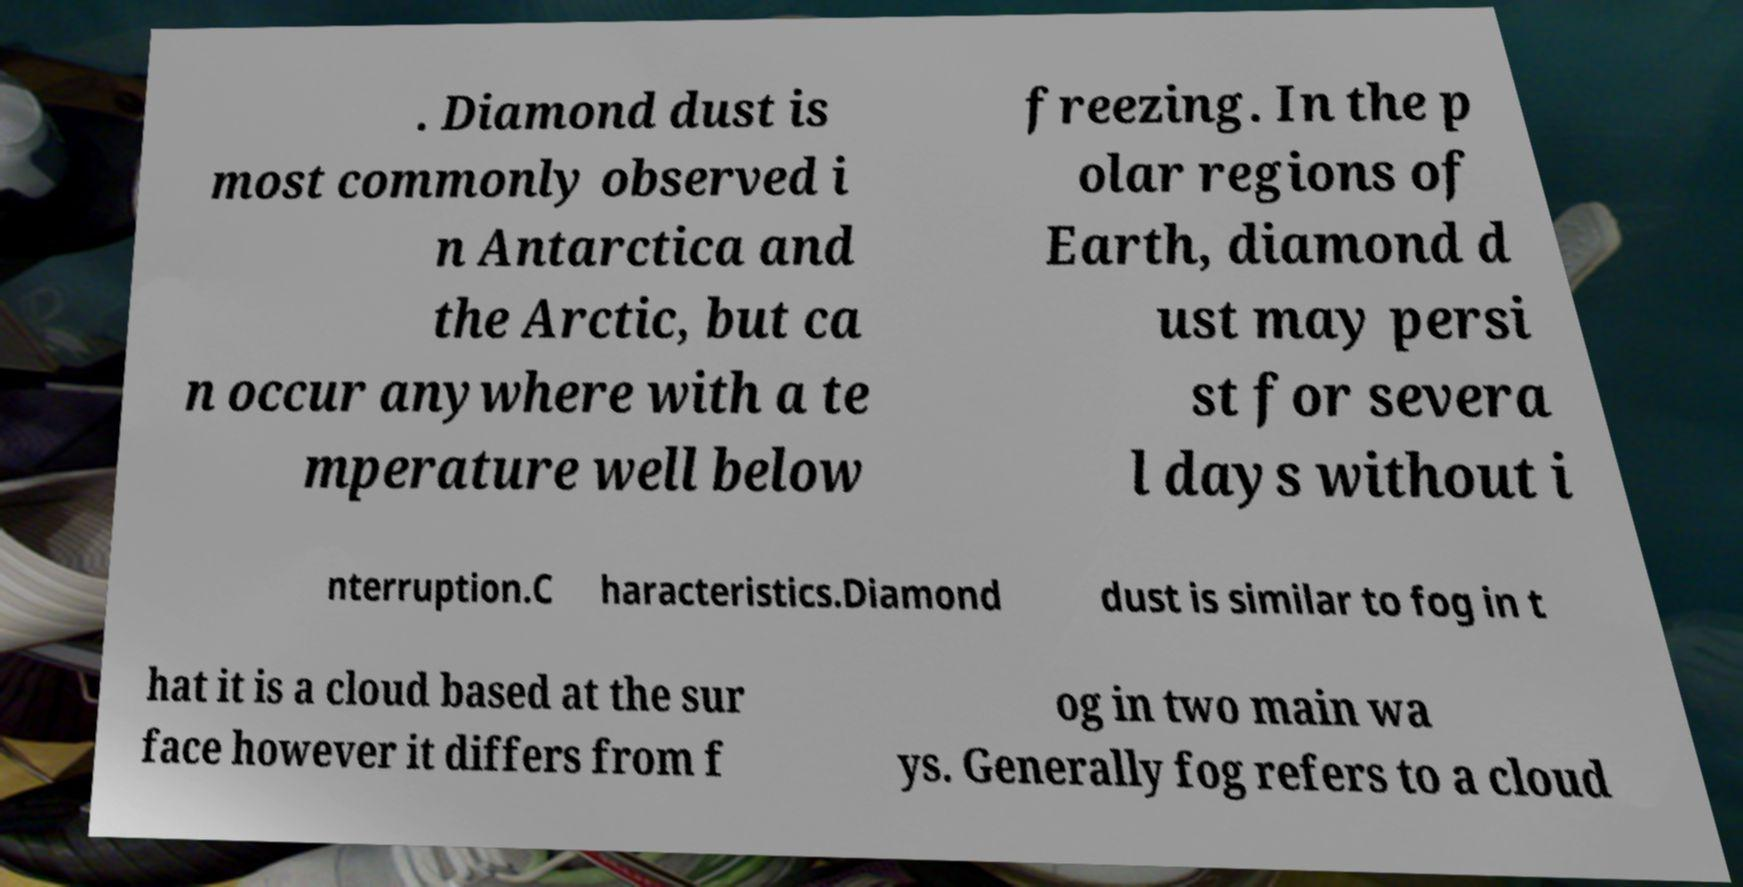Can you accurately transcribe the text from the provided image for me? . Diamond dust is most commonly observed i n Antarctica and the Arctic, but ca n occur anywhere with a te mperature well below freezing. In the p olar regions of Earth, diamond d ust may persi st for severa l days without i nterruption.C haracteristics.Diamond dust is similar to fog in t hat it is a cloud based at the sur face however it differs from f og in two main wa ys. Generally fog refers to a cloud 